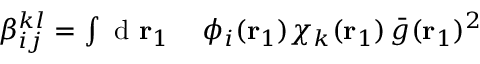Convert formula to latex. <formula><loc_0><loc_0><loc_500><loc_500>\begin{array} { r l } { \beta _ { i j } ^ { k l } = \int d { r _ { 1 } } } & \, \phi _ { i } ( { r _ { 1 } } ) \chi _ { k } ( { r _ { 1 } } ) \, \bar { g } ( { r _ { 1 } } ) ^ { 2 } } \end{array}</formula> 